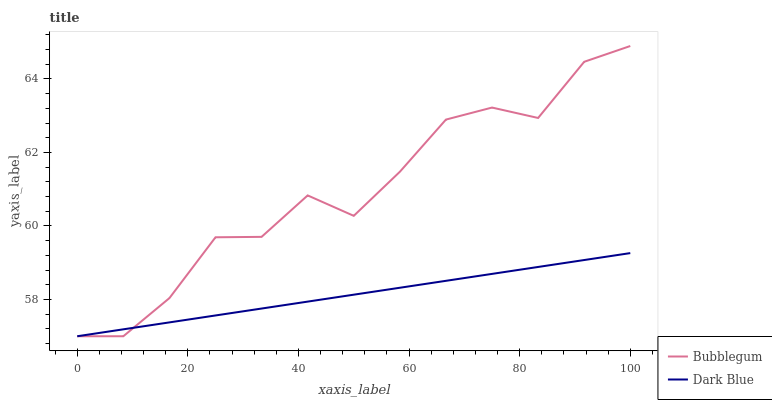Does Dark Blue have the minimum area under the curve?
Answer yes or no. Yes. Does Bubblegum have the maximum area under the curve?
Answer yes or no. Yes. Does Bubblegum have the minimum area under the curve?
Answer yes or no. No. Is Dark Blue the smoothest?
Answer yes or no. Yes. Is Bubblegum the roughest?
Answer yes or no. Yes. Is Bubblegum the smoothest?
Answer yes or no. No. Does Dark Blue have the lowest value?
Answer yes or no. Yes. Does Bubblegum have the highest value?
Answer yes or no. Yes. Does Dark Blue intersect Bubblegum?
Answer yes or no. Yes. Is Dark Blue less than Bubblegum?
Answer yes or no. No. Is Dark Blue greater than Bubblegum?
Answer yes or no. No. 